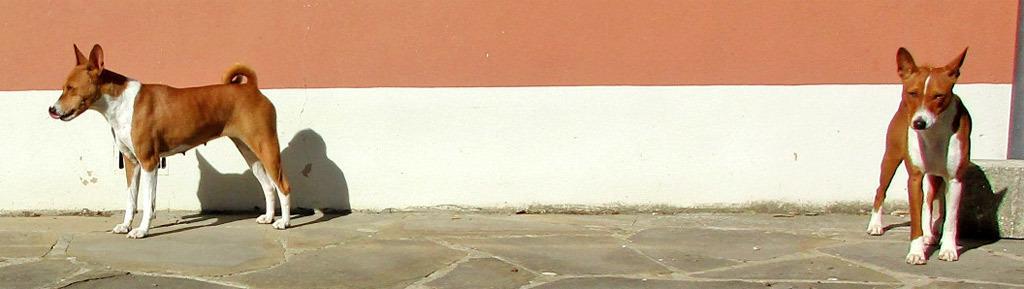In one or two sentences, can you explain what this image depicts? In this image we can see dogs standing on the floor. 